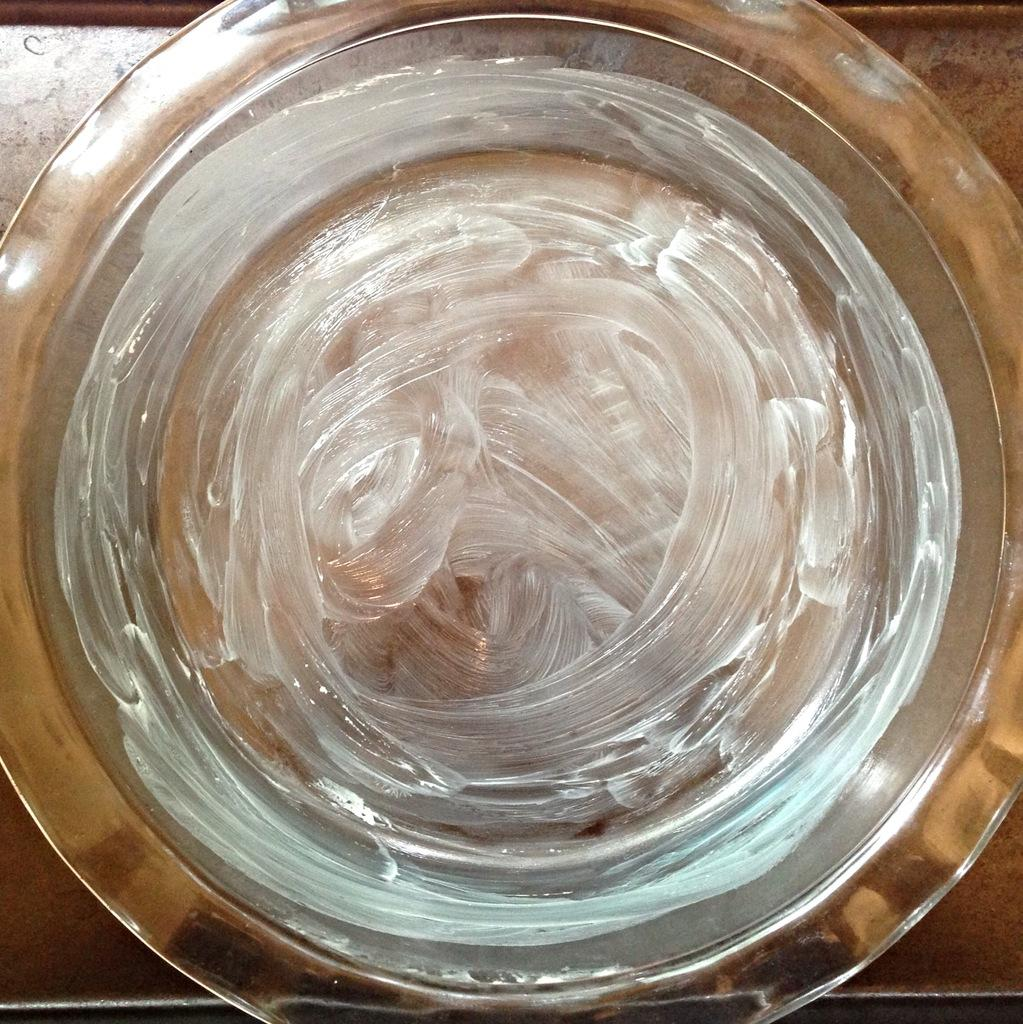What is in the bowl that is visible in the image? There is a greasy substance in a bowl in the image. What is the primary object visible at the bottom of the image? There is a table visible at the bottom of the image. What type of maid is cleaning the mist off the table in the image? There is no maid or mist present in the image. 